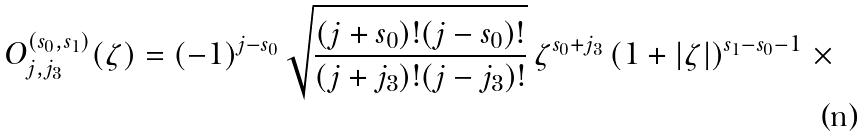<formula> <loc_0><loc_0><loc_500><loc_500>O ^ { ( s _ { 0 } , s _ { 1 } ) } _ { j , j _ { 3 } } ( \zeta ) = ( - 1 ) ^ { j - s _ { 0 } } \, \sqrt { \frac { ( j + s _ { 0 } ) ! ( j - s _ { 0 } ) ! } { ( j + j _ { 3 } ) ! ( j - j _ { 3 } ) ! } } \, \zeta ^ { s _ { 0 } + j _ { 3 } } \left ( 1 + | \zeta | \right ) ^ { s _ { 1 } - s _ { 0 } - 1 } \, \times</formula> 